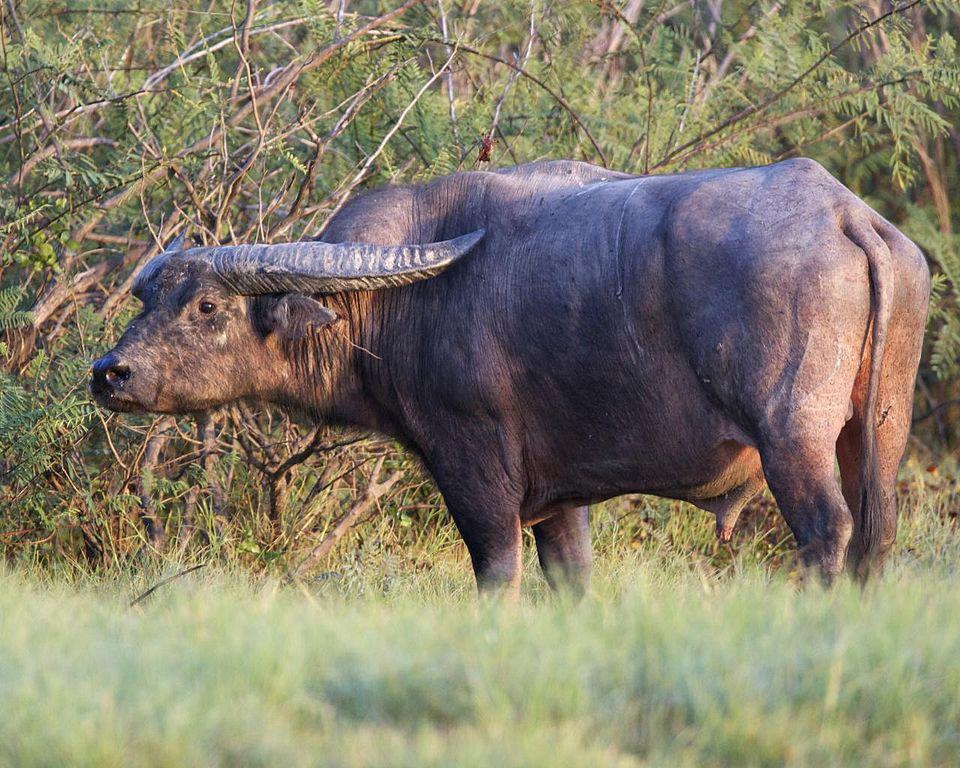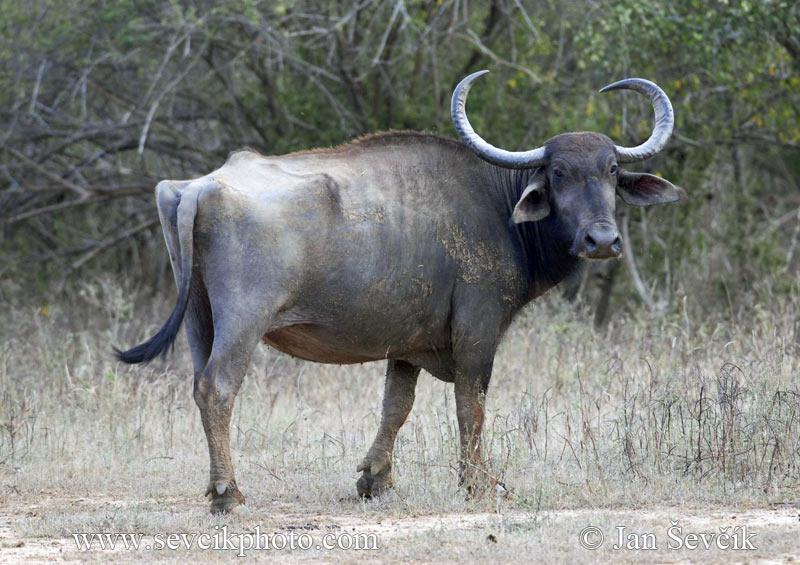The first image is the image on the left, the second image is the image on the right. Examine the images to the left and right. Is the description "The tail on the cow on the right is seen behind it." accurate? Answer yes or no. Yes. The first image is the image on the left, the second image is the image on the right. Given the left and right images, does the statement "There are two buffalos facing away from each other." hold true? Answer yes or no. Yes. 